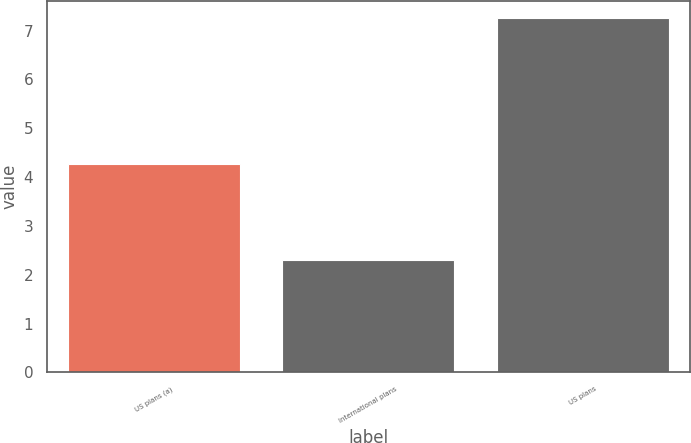<chart> <loc_0><loc_0><loc_500><loc_500><bar_chart><fcel>US plans (a)<fcel>International plans<fcel>US plans<nl><fcel>4.26<fcel>2.3<fcel>7.25<nl></chart> 